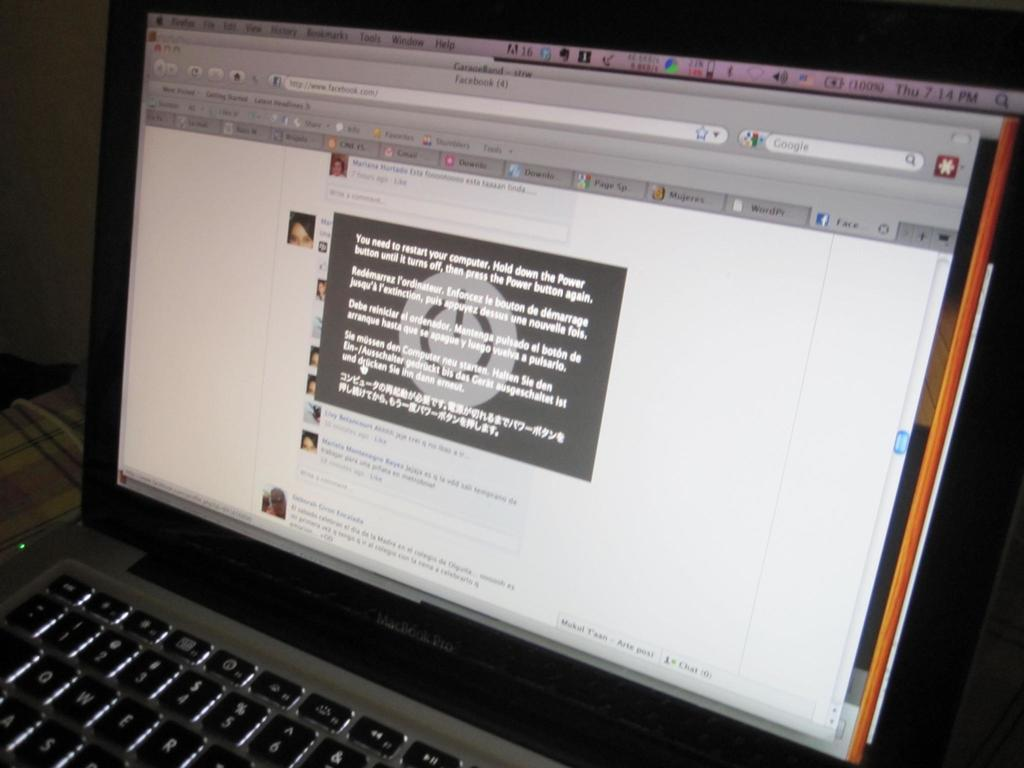<image>
Describe the image concisely. A laptop with a popup in Spanish around the time of 7:14 pm 